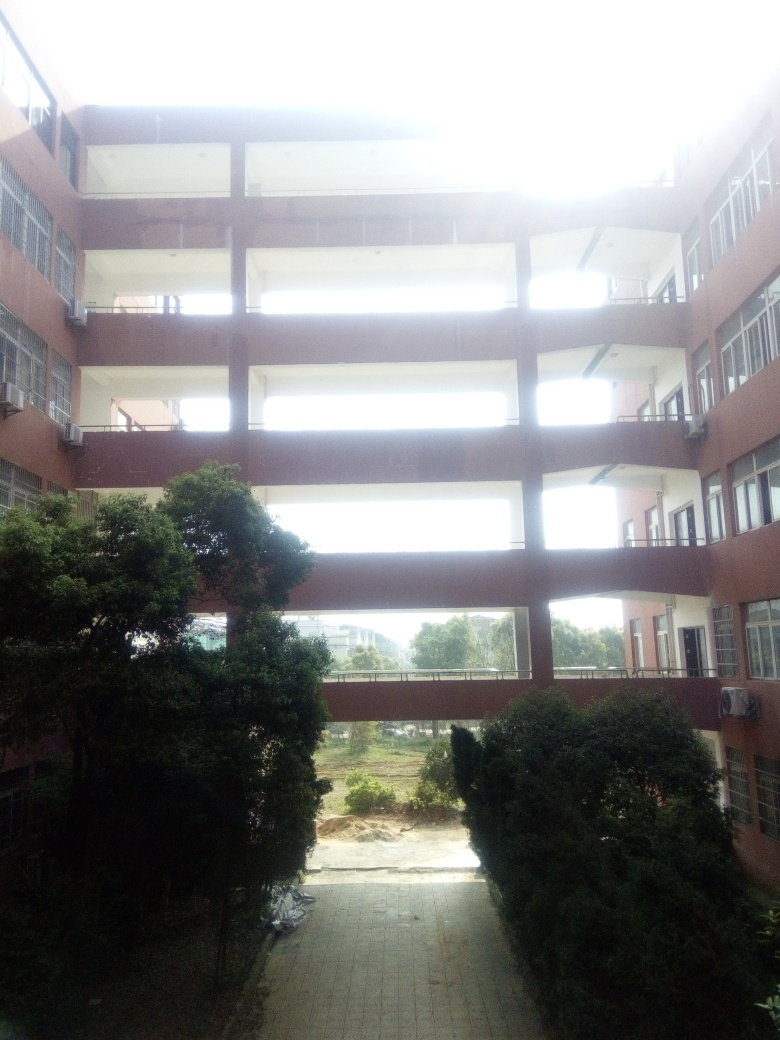Is the image clear? The image appears overexposed in certain areas, particularly the sky and some of the building's edges, resulting in a loss of detail. The composition is centered and provides a clear view of the building's structure and surrounding vegetation, but the brightness imbalance affects the overall clarity. 